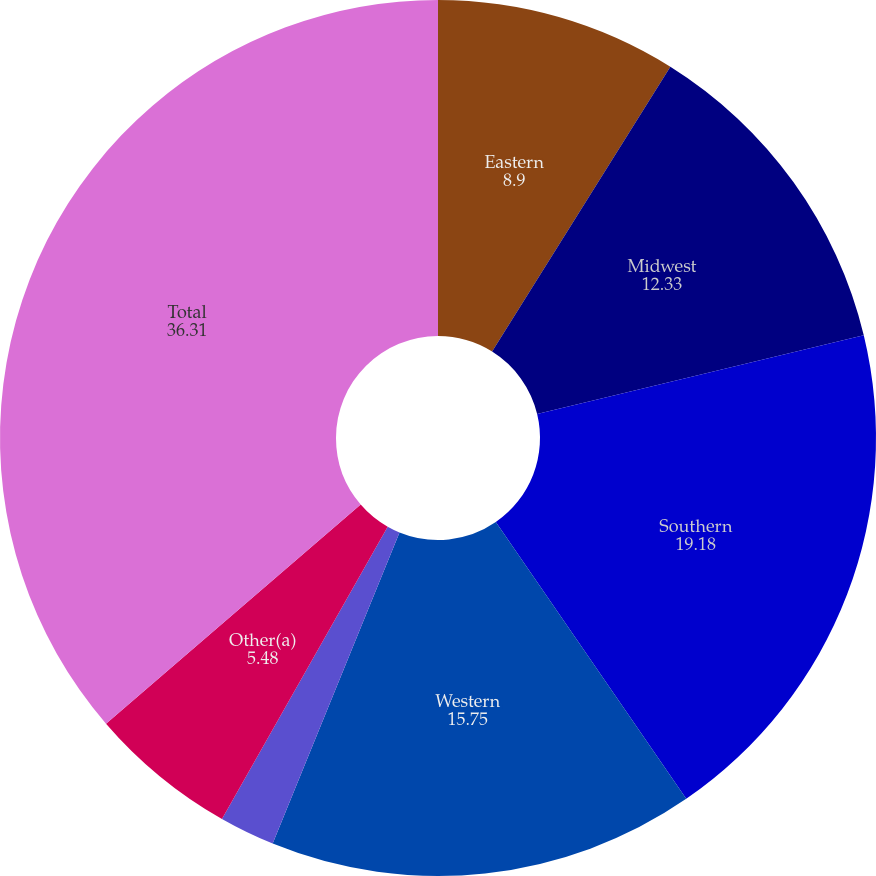Convert chart to OTSL. <chart><loc_0><loc_0><loc_500><loc_500><pie_chart><fcel>Eastern<fcel>Midwest<fcel>Southern<fcel>Western<fcel>Wheelabrator<fcel>Other(a)<fcel>Total<nl><fcel>8.9%<fcel>12.33%<fcel>19.18%<fcel>15.75%<fcel>2.05%<fcel>5.48%<fcel>36.31%<nl></chart> 